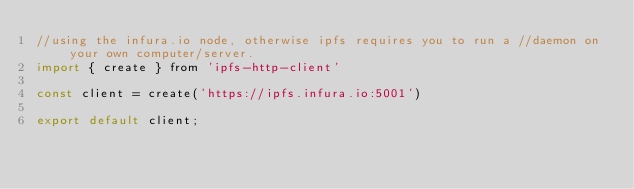Convert code to text. <code><loc_0><loc_0><loc_500><loc_500><_JavaScript_>//using the infura.io node, otherwise ipfs requires you to run a //daemon on your own computer/server.
import { create } from 'ipfs-http-client'

const client = create('https://ipfs.infura.io:5001')

export default client;</code> 